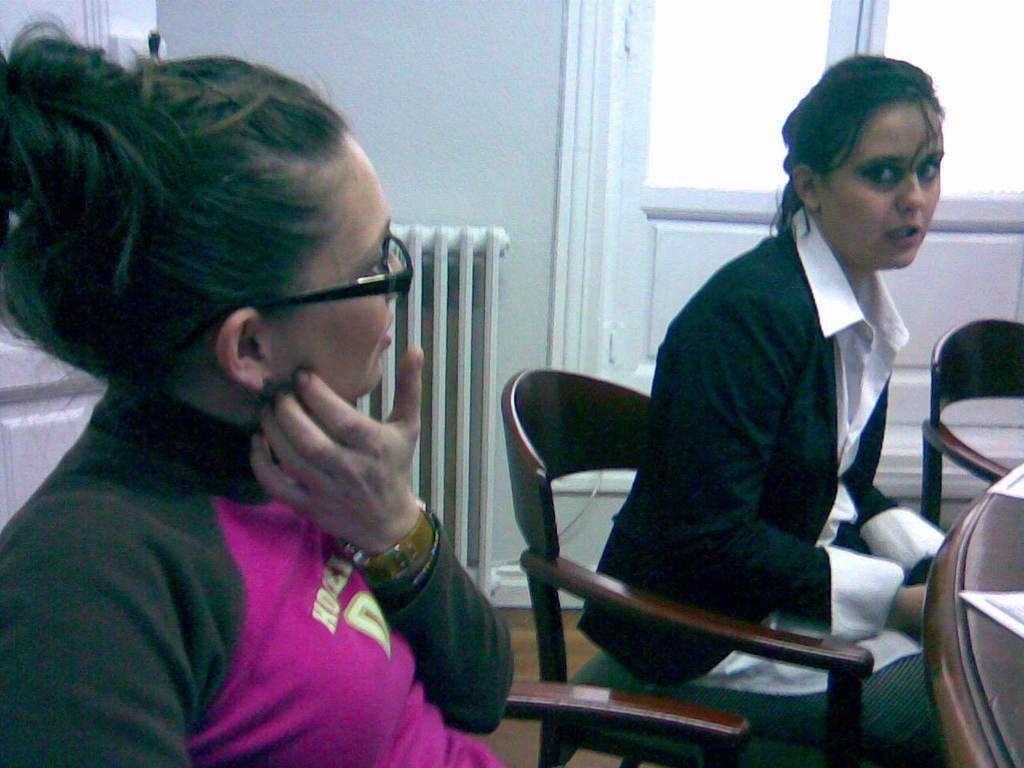In one or two sentences, can you explain what this image depicts? In this image there are two women sitting on chairs, in front of them there is a table, in the background there is a wall for that wall there is a door. 